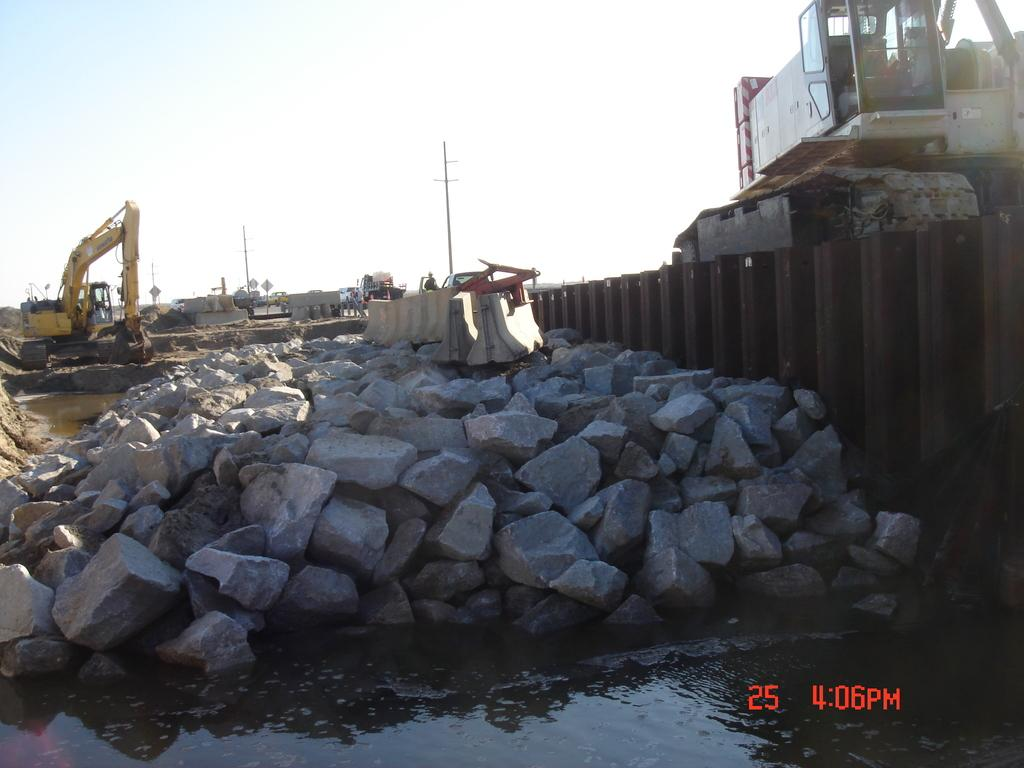What type of natural elements can be seen in the image? There are rocks and water visible in the image. What type of man-made structure is present in the image? There is an iron grill in the image. What type of terrain is visible in the image? There is sand visible in the image. What type of construction equipment is present in the image? There are excavators in the image. What type of vertical structures are present in the image? There are poles in the image. What part of the natural environment is visible in the image? The sky is visible in the image. How many quince are hanging from the poles in the image? There are no quince present in the image. Can you see any bikes in the image? There are no bikes present in the image. How many ducks are swimming in the water in the image? There are no ducks present in the image. 